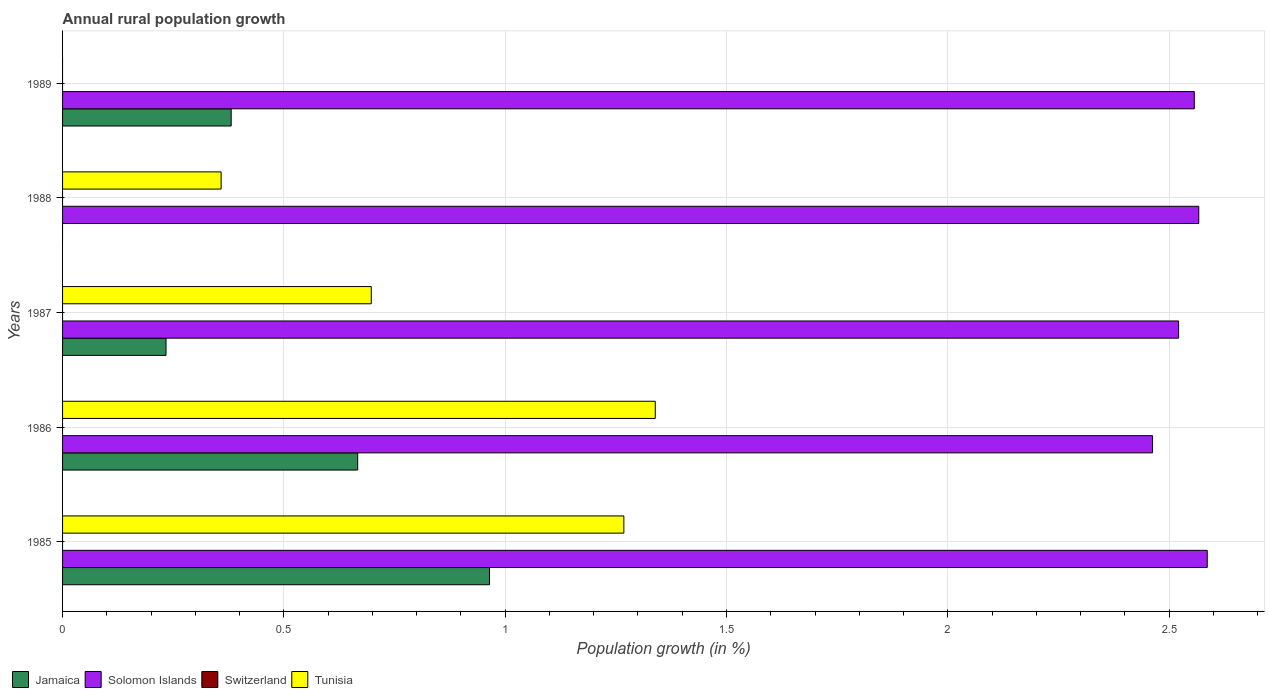Are the number of bars per tick equal to the number of legend labels?
Provide a succinct answer. No. How many bars are there on the 1st tick from the bottom?
Make the answer very short. 3. What is the percentage of rural population growth in Tunisia in 1985?
Your answer should be compact. 1.27. Across all years, what is the maximum percentage of rural population growth in Solomon Islands?
Your answer should be very brief. 2.59. Across all years, what is the minimum percentage of rural population growth in Jamaica?
Offer a very short reply. 0. In which year was the percentage of rural population growth in Jamaica maximum?
Offer a very short reply. 1985. What is the total percentage of rural population growth in Jamaica in the graph?
Provide a succinct answer. 2.25. What is the difference between the percentage of rural population growth in Tunisia in 1986 and that in 1988?
Offer a very short reply. 0.98. What is the difference between the percentage of rural population growth in Jamaica in 1988 and the percentage of rural population growth in Tunisia in 1985?
Offer a very short reply. -1.27. What is the average percentage of rural population growth in Solomon Islands per year?
Ensure brevity in your answer.  2.54. In the year 1989, what is the difference between the percentage of rural population growth in Jamaica and percentage of rural population growth in Solomon Islands?
Provide a short and direct response. -2.18. In how many years, is the percentage of rural population growth in Switzerland greater than 0.9 %?
Make the answer very short. 0. What is the ratio of the percentage of rural population growth in Solomon Islands in 1986 to that in 1987?
Your answer should be very brief. 0.98. Is the percentage of rural population growth in Tunisia in 1985 less than that in 1987?
Give a very brief answer. No. Is the difference between the percentage of rural population growth in Jamaica in 1985 and 1986 greater than the difference between the percentage of rural population growth in Solomon Islands in 1985 and 1986?
Your response must be concise. Yes. What is the difference between the highest and the second highest percentage of rural population growth in Tunisia?
Your answer should be very brief. 0.07. What is the difference between the highest and the lowest percentage of rural population growth in Jamaica?
Give a very brief answer. 0.96. Is the sum of the percentage of rural population growth in Solomon Islands in 1986 and 1987 greater than the maximum percentage of rural population growth in Switzerland across all years?
Ensure brevity in your answer.  Yes. How many bars are there?
Your response must be concise. 13. Are all the bars in the graph horizontal?
Make the answer very short. Yes. How many years are there in the graph?
Ensure brevity in your answer.  5. What is the difference between two consecutive major ticks on the X-axis?
Give a very brief answer. 0.5. Does the graph contain grids?
Give a very brief answer. Yes. Where does the legend appear in the graph?
Keep it short and to the point. Bottom left. How many legend labels are there?
Offer a terse response. 4. How are the legend labels stacked?
Offer a very short reply. Horizontal. What is the title of the graph?
Offer a terse response. Annual rural population growth. Does "World" appear as one of the legend labels in the graph?
Your answer should be very brief. No. What is the label or title of the X-axis?
Keep it short and to the point. Population growth (in %). What is the label or title of the Y-axis?
Provide a succinct answer. Years. What is the Population growth (in %) of Jamaica in 1985?
Provide a short and direct response. 0.96. What is the Population growth (in %) of Solomon Islands in 1985?
Make the answer very short. 2.59. What is the Population growth (in %) in Tunisia in 1985?
Offer a terse response. 1.27. What is the Population growth (in %) in Jamaica in 1986?
Your answer should be very brief. 0.67. What is the Population growth (in %) in Solomon Islands in 1986?
Your answer should be compact. 2.46. What is the Population growth (in %) of Switzerland in 1986?
Give a very brief answer. 0. What is the Population growth (in %) of Tunisia in 1986?
Offer a terse response. 1.34. What is the Population growth (in %) of Jamaica in 1987?
Your response must be concise. 0.23. What is the Population growth (in %) of Solomon Islands in 1987?
Your response must be concise. 2.52. What is the Population growth (in %) of Tunisia in 1987?
Offer a terse response. 0.7. What is the Population growth (in %) in Solomon Islands in 1988?
Provide a succinct answer. 2.57. What is the Population growth (in %) of Switzerland in 1988?
Keep it short and to the point. 0. What is the Population growth (in %) of Tunisia in 1988?
Ensure brevity in your answer.  0.36. What is the Population growth (in %) of Jamaica in 1989?
Your response must be concise. 0.38. What is the Population growth (in %) of Solomon Islands in 1989?
Give a very brief answer. 2.56. Across all years, what is the maximum Population growth (in %) of Jamaica?
Provide a succinct answer. 0.96. Across all years, what is the maximum Population growth (in %) of Solomon Islands?
Your answer should be very brief. 2.59. Across all years, what is the maximum Population growth (in %) in Tunisia?
Your answer should be compact. 1.34. Across all years, what is the minimum Population growth (in %) in Solomon Islands?
Give a very brief answer. 2.46. Across all years, what is the minimum Population growth (in %) in Tunisia?
Your response must be concise. 0. What is the total Population growth (in %) of Jamaica in the graph?
Provide a short and direct response. 2.25. What is the total Population growth (in %) of Solomon Islands in the graph?
Keep it short and to the point. 12.69. What is the total Population growth (in %) in Tunisia in the graph?
Ensure brevity in your answer.  3.66. What is the difference between the Population growth (in %) of Jamaica in 1985 and that in 1986?
Your answer should be very brief. 0.3. What is the difference between the Population growth (in %) of Solomon Islands in 1985 and that in 1986?
Offer a very short reply. 0.12. What is the difference between the Population growth (in %) in Tunisia in 1985 and that in 1986?
Make the answer very short. -0.07. What is the difference between the Population growth (in %) in Jamaica in 1985 and that in 1987?
Give a very brief answer. 0.73. What is the difference between the Population growth (in %) of Solomon Islands in 1985 and that in 1987?
Your answer should be compact. 0.06. What is the difference between the Population growth (in %) in Tunisia in 1985 and that in 1987?
Provide a succinct answer. 0.57. What is the difference between the Population growth (in %) of Solomon Islands in 1985 and that in 1988?
Your response must be concise. 0.02. What is the difference between the Population growth (in %) of Tunisia in 1985 and that in 1988?
Keep it short and to the point. 0.91. What is the difference between the Population growth (in %) in Jamaica in 1985 and that in 1989?
Offer a terse response. 0.58. What is the difference between the Population growth (in %) in Solomon Islands in 1985 and that in 1989?
Offer a very short reply. 0.03. What is the difference between the Population growth (in %) of Jamaica in 1986 and that in 1987?
Provide a short and direct response. 0.43. What is the difference between the Population growth (in %) of Solomon Islands in 1986 and that in 1987?
Ensure brevity in your answer.  -0.06. What is the difference between the Population growth (in %) in Tunisia in 1986 and that in 1987?
Make the answer very short. 0.64. What is the difference between the Population growth (in %) in Solomon Islands in 1986 and that in 1988?
Make the answer very short. -0.1. What is the difference between the Population growth (in %) in Tunisia in 1986 and that in 1988?
Provide a short and direct response. 0.98. What is the difference between the Population growth (in %) in Jamaica in 1986 and that in 1989?
Your answer should be very brief. 0.29. What is the difference between the Population growth (in %) of Solomon Islands in 1986 and that in 1989?
Your response must be concise. -0.09. What is the difference between the Population growth (in %) of Solomon Islands in 1987 and that in 1988?
Ensure brevity in your answer.  -0.05. What is the difference between the Population growth (in %) of Tunisia in 1987 and that in 1988?
Ensure brevity in your answer.  0.34. What is the difference between the Population growth (in %) in Jamaica in 1987 and that in 1989?
Make the answer very short. -0.15. What is the difference between the Population growth (in %) of Solomon Islands in 1987 and that in 1989?
Offer a terse response. -0.04. What is the difference between the Population growth (in %) in Solomon Islands in 1988 and that in 1989?
Offer a terse response. 0.01. What is the difference between the Population growth (in %) in Jamaica in 1985 and the Population growth (in %) in Solomon Islands in 1986?
Give a very brief answer. -1.5. What is the difference between the Population growth (in %) in Jamaica in 1985 and the Population growth (in %) in Tunisia in 1986?
Offer a very short reply. -0.37. What is the difference between the Population growth (in %) of Solomon Islands in 1985 and the Population growth (in %) of Tunisia in 1986?
Offer a very short reply. 1.25. What is the difference between the Population growth (in %) of Jamaica in 1985 and the Population growth (in %) of Solomon Islands in 1987?
Keep it short and to the point. -1.56. What is the difference between the Population growth (in %) of Jamaica in 1985 and the Population growth (in %) of Tunisia in 1987?
Offer a terse response. 0.27. What is the difference between the Population growth (in %) in Solomon Islands in 1985 and the Population growth (in %) in Tunisia in 1987?
Offer a terse response. 1.89. What is the difference between the Population growth (in %) in Jamaica in 1985 and the Population growth (in %) in Solomon Islands in 1988?
Ensure brevity in your answer.  -1.6. What is the difference between the Population growth (in %) in Jamaica in 1985 and the Population growth (in %) in Tunisia in 1988?
Give a very brief answer. 0.61. What is the difference between the Population growth (in %) of Solomon Islands in 1985 and the Population growth (in %) of Tunisia in 1988?
Your answer should be compact. 2.23. What is the difference between the Population growth (in %) in Jamaica in 1985 and the Population growth (in %) in Solomon Islands in 1989?
Your answer should be very brief. -1.59. What is the difference between the Population growth (in %) of Jamaica in 1986 and the Population growth (in %) of Solomon Islands in 1987?
Offer a very short reply. -1.85. What is the difference between the Population growth (in %) in Jamaica in 1986 and the Population growth (in %) in Tunisia in 1987?
Your response must be concise. -0.03. What is the difference between the Population growth (in %) of Solomon Islands in 1986 and the Population growth (in %) of Tunisia in 1987?
Offer a very short reply. 1.77. What is the difference between the Population growth (in %) of Jamaica in 1986 and the Population growth (in %) of Solomon Islands in 1988?
Your answer should be very brief. -1.9. What is the difference between the Population growth (in %) in Jamaica in 1986 and the Population growth (in %) in Tunisia in 1988?
Offer a very short reply. 0.31. What is the difference between the Population growth (in %) in Solomon Islands in 1986 and the Population growth (in %) in Tunisia in 1988?
Provide a short and direct response. 2.1. What is the difference between the Population growth (in %) of Jamaica in 1986 and the Population growth (in %) of Solomon Islands in 1989?
Offer a very short reply. -1.89. What is the difference between the Population growth (in %) in Jamaica in 1987 and the Population growth (in %) in Solomon Islands in 1988?
Give a very brief answer. -2.33. What is the difference between the Population growth (in %) of Jamaica in 1987 and the Population growth (in %) of Tunisia in 1988?
Keep it short and to the point. -0.12. What is the difference between the Population growth (in %) of Solomon Islands in 1987 and the Population growth (in %) of Tunisia in 1988?
Make the answer very short. 2.16. What is the difference between the Population growth (in %) of Jamaica in 1987 and the Population growth (in %) of Solomon Islands in 1989?
Provide a succinct answer. -2.32. What is the average Population growth (in %) of Jamaica per year?
Give a very brief answer. 0.45. What is the average Population growth (in %) of Solomon Islands per year?
Give a very brief answer. 2.54. What is the average Population growth (in %) in Switzerland per year?
Provide a short and direct response. 0. What is the average Population growth (in %) in Tunisia per year?
Give a very brief answer. 0.73. In the year 1985, what is the difference between the Population growth (in %) of Jamaica and Population growth (in %) of Solomon Islands?
Provide a short and direct response. -1.62. In the year 1985, what is the difference between the Population growth (in %) in Jamaica and Population growth (in %) in Tunisia?
Your answer should be very brief. -0.3. In the year 1985, what is the difference between the Population growth (in %) of Solomon Islands and Population growth (in %) of Tunisia?
Your answer should be very brief. 1.32. In the year 1986, what is the difference between the Population growth (in %) of Jamaica and Population growth (in %) of Solomon Islands?
Your answer should be very brief. -1.8. In the year 1986, what is the difference between the Population growth (in %) in Jamaica and Population growth (in %) in Tunisia?
Offer a terse response. -0.67. In the year 1986, what is the difference between the Population growth (in %) in Solomon Islands and Population growth (in %) in Tunisia?
Ensure brevity in your answer.  1.12. In the year 1987, what is the difference between the Population growth (in %) in Jamaica and Population growth (in %) in Solomon Islands?
Keep it short and to the point. -2.29. In the year 1987, what is the difference between the Population growth (in %) of Jamaica and Population growth (in %) of Tunisia?
Offer a very short reply. -0.46. In the year 1987, what is the difference between the Population growth (in %) of Solomon Islands and Population growth (in %) of Tunisia?
Give a very brief answer. 1.82. In the year 1988, what is the difference between the Population growth (in %) in Solomon Islands and Population growth (in %) in Tunisia?
Your response must be concise. 2.21. In the year 1989, what is the difference between the Population growth (in %) of Jamaica and Population growth (in %) of Solomon Islands?
Your response must be concise. -2.18. What is the ratio of the Population growth (in %) of Jamaica in 1985 to that in 1986?
Offer a very short reply. 1.45. What is the ratio of the Population growth (in %) of Solomon Islands in 1985 to that in 1986?
Provide a short and direct response. 1.05. What is the ratio of the Population growth (in %) of Tunisia in 1985 to that in 1986?
Provide a succinct answer. 0.95. What is the ratio of the Population growth (in %) of Jamaica in 1985 to that in 1987?
Offer a very short reply. 4.13. What is the ratio of the Population growth (in %) in Solomon Islands in 1985 to that in 1987?
Give a very brief answer. 1.03. What is the ratio of the Population growth (in %) in Tunisia in 1985 to that in 1987?
Give a very brief answer. 1.82. What is the ratio of the Population growth (in %) in Solomon Islands in 1985 to that in 1988?
Keep it short and to the point. 1.01. What is the ratio of the Population growth (in %) in Tunisia in 1985 to that in 1988?
Offer a very short reply. 3.54. What is the ratio of the Population growth (in %) of Jamaica in 1985 to that in 1989?
Offer a very short reply. 2.53. What is the ratio of the Population growth (in %) in Solomon Islands in 1985 to that in 1989?
Ensure brevity in your answer.  1.01. What is the ratio of the Population growth (in %) in Jamaica in 1986 to that in 1987?
Give a very brief answer. 2.85. What is the ratio of the Population growth (in %) of Solomon Islands in 1986 to that in 1987?
Make the answer very short. 0.98. What is the ratio of the Population growth (in %) in Tunisia in 1986 to that in 1987?
Offer a very short reply. 1.92. What is the ratio of the Population growth (in %) of Solomon Islands in 1986 to that in 1988?
Ensure brevity in your answer.  0.96. What is the ratio of the Population growth (in %) in Tunisia in 1986 to that in 1988?
Provide a succinct answer. 3.74. What is the ratio of the Population growth (in %) in Jamaica in 1986 to that in 1989?
Give a very brief answer. 1.75. What is the ratio of the Population growth (in %) in Solomon Islands in 1986 to that in 1989?
Your answer should be compact. 0.96. What is the ratio of the Population growth (in %) of Solomon Islands in 1987 to that in 1988?
Your response must be concise. 0.98. What is the ratio of the Population growth (in %) in Tunisia in 1987 to that in 1988?
Your answer should be very brief. 1.95. What is the ratio of the Population growth (in %) in Jamaica in 1987 to that in 1989?
Ensure brevity in your answer.  0.61. What is the ratio of the Population growth (in %) in Solomon Islands in 1987 to that in 1989?
Keep it short and to the point. 0.99. What is the difference between the highest and the second highest Population growth (in %) in Jamaica?
Offer a very short reply. 0.3. What is the difference between the highest and the second highest Population growth (in %) of Solomon Islands?
Offer a very short reply. 0.02. What is the difference between the highest and the second highest Population growth (in %) in Tunisia?
Your answer should be compact. 0.07. What is the difference between the highest and the lowest Population growth (in %) in Jamaica?
Provide a succinct answer. 0.96. What is the difference between the highest and the lowest Population growth (in %) in Solomon Islands?
Offer a terse response. 0.12. What is the difference between the highest and the lowest Population growth (in %) in Tunisia?
Ensure brevity in your answer.  1.34. 